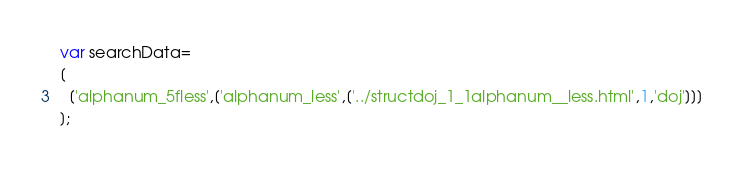Convert code to text. <code><loc_0><loc_0><loc_500><loc_500><_JavaScript_>var searchData=
[
  ['alphanum_5fless',['alphanum_less',['../structdoj_1_1alphanum__less.html',1,'doj']]]
];
</code> 